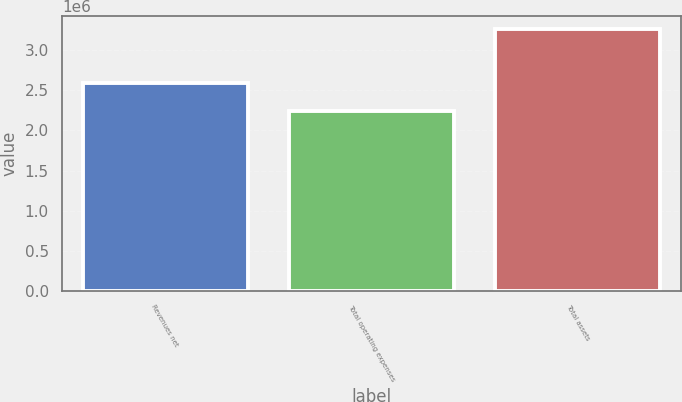Convert chart to OTSL. <chart><loc_0><loc_0><loc_500><loc_500><bar_chart><fcel>Revenues net<fcel>Total operating expenses<fcel>Total assets<nl><fcel>2.59333e+06<fcel>2.24666e+06<fcel>3.26467e+06<nl></chart> 